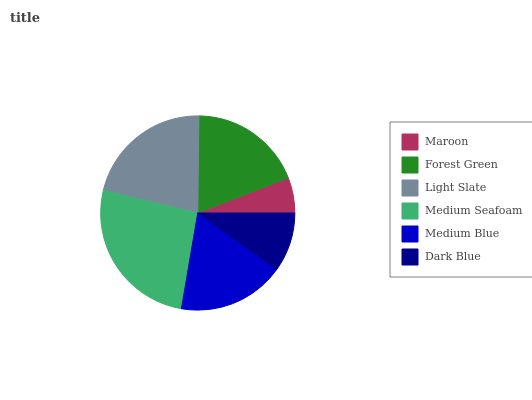Is Maroon the minimum?
Answer yes or no. Yes. Is Medium Seafoam the maximum?
Answer yes or no. Yes. Is Forest Green the minimum?
Answer yes or no. No. Is Forest Green the maximum?
Answer yes or no. No. Is Forest Green greater than Maroon?
Answer yes or no. Yes. Is Maroon less than Forest Green?
Answer yes or no. Yes. Is Maroon greater than Forest Green?
Answer yes or no. No. Is Forest Green less than Maroon?
Answer yes or no. No. Is Forest Green the high median?
Answer yes or no. Yes. Is Medium Blue the low median?
Answer yes or no. Yes. Is Light Slate the high median?
Answer yes or no. No. Is Light Slate the low median?
Answer yes or no. No. 